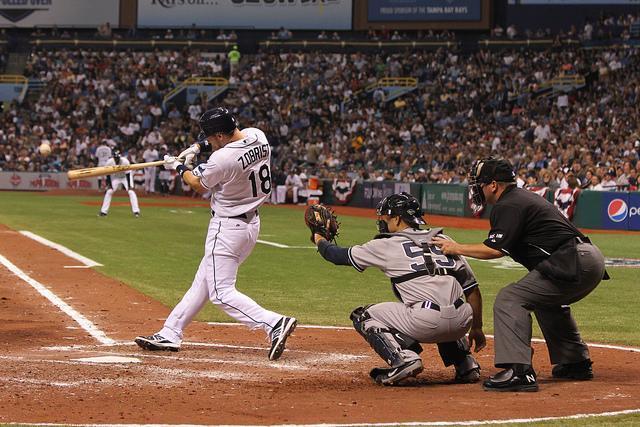How many people can be seen?
Give a very brief answer. 4. How many birds are there?
Give a very brief answer. 0. 